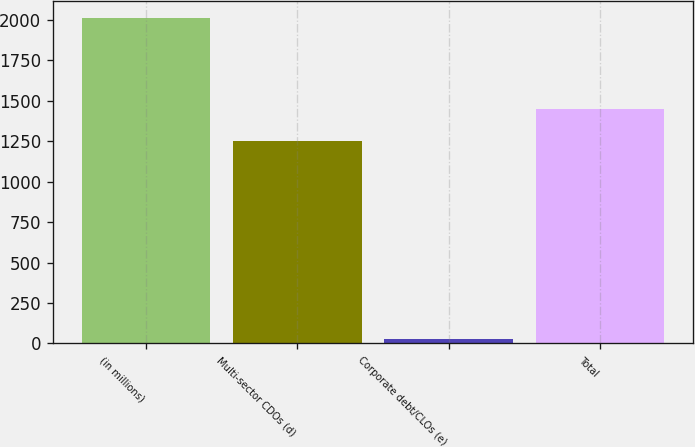Convert chart to OTSL. <chart><loc_0><loc_0><loc_500><loc_500><bar_chart><fcel>(in millions)<fcel>Multi-sector CDOs (d)<fcel>Corporate debt/CLOs (e)<fcel>Total<nl><fcel>2013<fcel>1249<fcel>28<fcel>1447.5<nl></chart> 